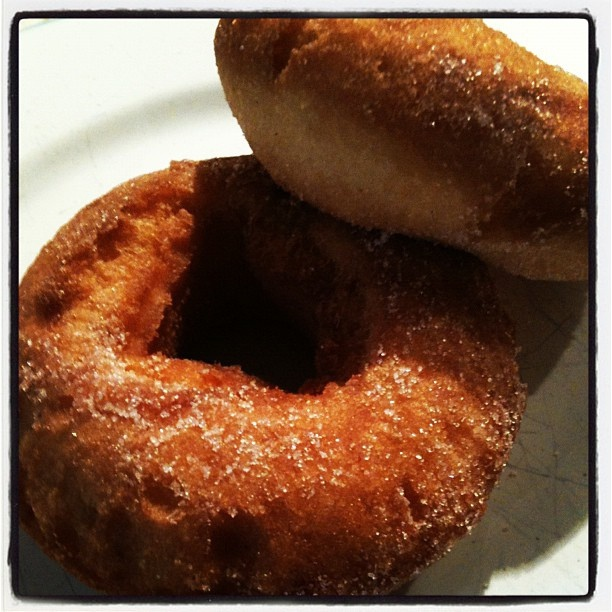Describe the objects in this image and their specific colors. I can see donut in white, black, maroon, and brown tones and donut in white, maroon, black, and brown tones in this image. 